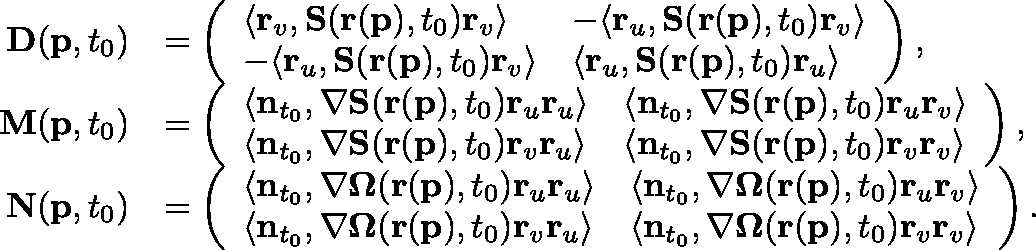Convert formula to latex. <formula><loc_0><loc_0><loc_500><loc_500>\begin{array} { r l } { D ( p , t _ { 0 } ) } & { = \left ( \begin{array} { l l } { \langle r _ { v } , S ( r ( p ) , t _ { 0 } ) r _ { v } \rangle } & { - \langle r _ { u } , S ( r ( p ) , t _ { 0 } ) r _ { v } \rangle } \\ { - \langle r _ { u } , S ( r ( p ) , t _ { 0 } ) r _ { v } \rangle } & { \langle r _ { u } , S ( r ( p ) , t _ { 0 } ) r _ { u } \rangle } \end{array} \right ) , } \\ { M ( p , t _ { 0 } ) } & { = \left ( \begin{array} { l l } { \langle n _ { t _ { 0 } } , \nabla S ( r ( p ) , t _ { 0 } ) r _ { u } r _ { u } \rangle } & { \langle n _ { t _ { 0 } } , \nabla S ( r ( p ) , t _ { 0 } ) r _ { u } r _ { v } \rangle } \\ { \langle n _ { t _ { 0 } } , \nabla S ( r ( p ) , t _ { 0 } ) r _ { v } r _ { u } \rangle } & { \langle n _ { t _ { 0 } } , \nabla S ( r ( p ) , t _ { 0 } ) r _ { v } r _ { v } \rangle } \end{array} \right ) , } \\ { N ( p , t _ { 0 } ) } & { = \left ( \begin{array} { l l } { \langle n _ { t _ { 0 } } , \nabla \Omega ( r ( p ) , t _ { 0 } ) r _ { u } r _ { u } \rangle } & { \langle n _ { t _ { 0 } } , \nabla \Omega ( r ( p ) , t _ { 0 } ) r _ { u } r _ { v } \rangle } \\ { \langle n _ { t _ { 0 } } , \nabla \Omega ( r ( p ) , t _ { 0 } ) r _ { v } r _ { u } \rangle } & { \langle n _ { t _ { 0 } } , \nabla \Omega ( r ( p ) , t _ { 0 } ) r _ { v } r _ { v } \rangle } \end{array} \right ) . } \end{array}</formula> 